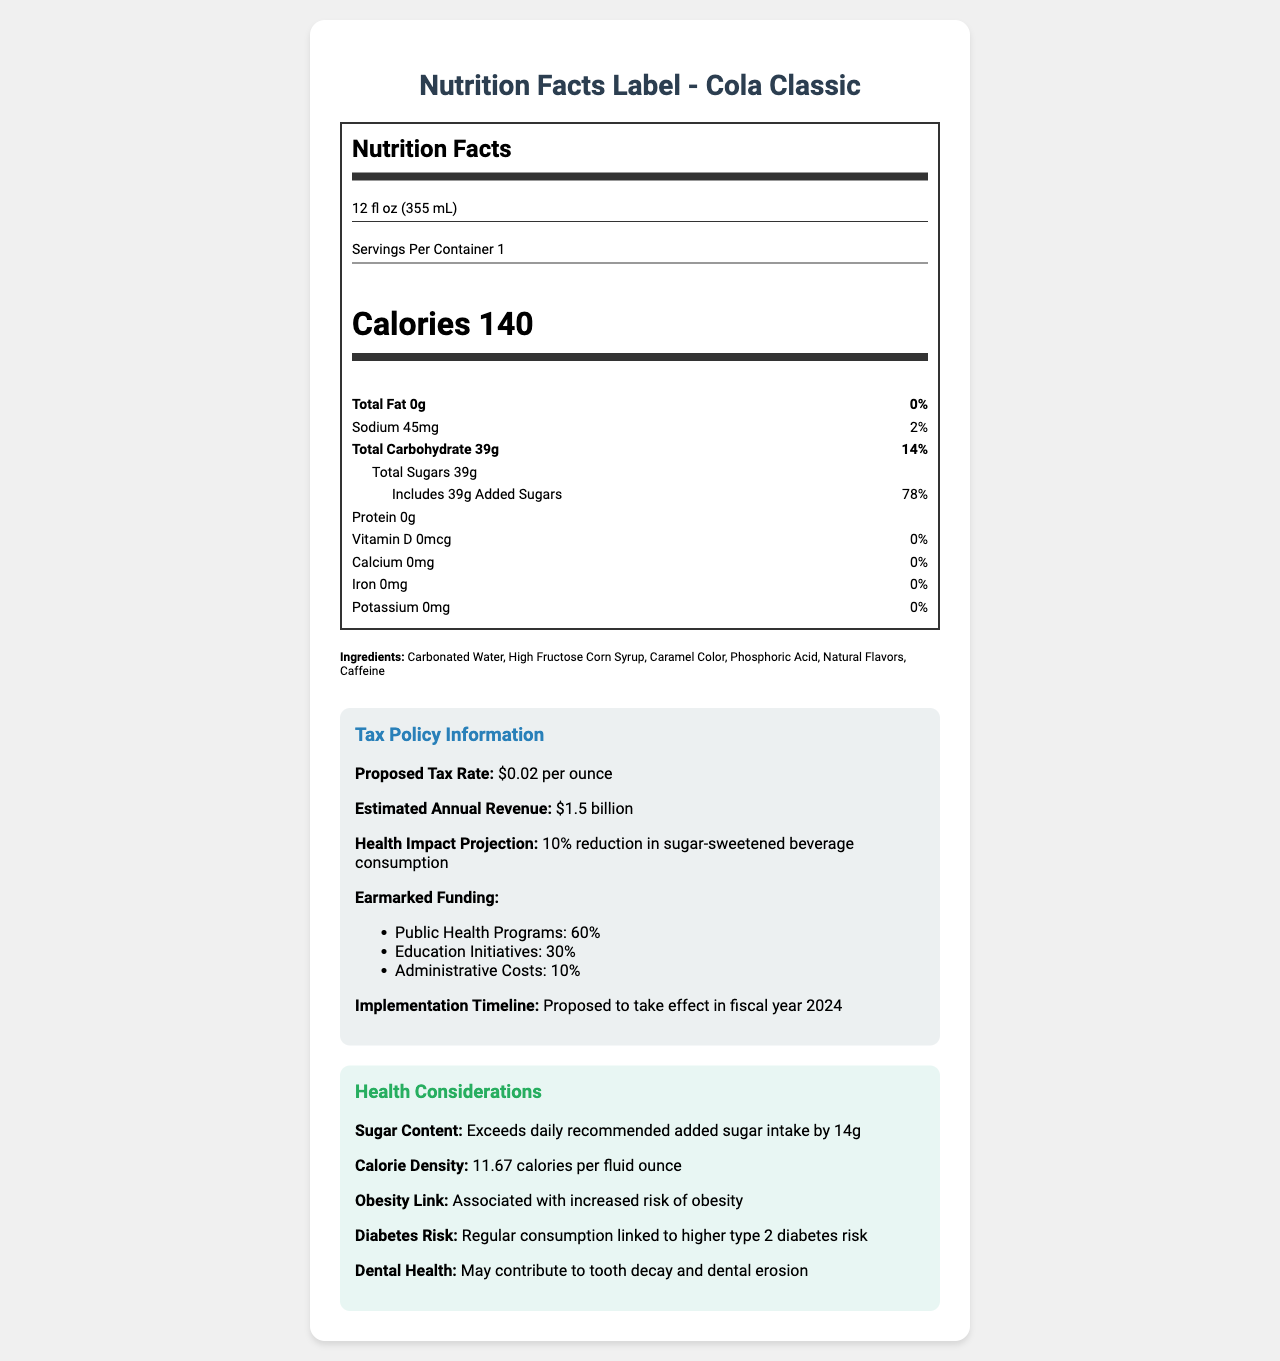what is the serving size of Cola Classic? The serving size is explicitly mentioned at the top of the Nutrition Facts section as "12 fl oz (355 mL)."
Answer: 12 fl oz (355 mL) How many calories are in one serving? The number of calories per serving is highlighted in bold and large font in the Nutrition Facts section as "Calories 140."
Answer: 140 calories What is the total carbohydrate content per serving? Under "Total Carbohydrate," the amount is listed as 39g.
Answer: 39g How much of the total carbohydrate content is sugar? The document specifies "Total Sugars" as 39g, which is the same as the total carbohydrate content, implying all the carbs come from sugar.
Answer: 39g Which ingredient is listed first in the ingredients list? The ingredients are listed in descending order of predominance by weight, and the first ingredient listed is "Carbonated Water."
Answer: Carbonated Water What is the proposed tax rate for sugar-sweetened beverages? This information is found in the Tax Policy Information section under "Proposed Tax Rate."
Answer: $0.02 per ounce How much revenue is the proposed tax expected to generate annually? The estimated annual revenue is mentioned as "$1.5 billion."
Answer: $1.5 billion How much of the proposed tax revenue is earmarked for public health programs? A. 10% B. 30% C. 60% D. 90% The Earmarked Funding section states that 60% of the revenue will go to Public Health Programs.
Answer: C What is the daily value percentage for added sugars in one serving? A. 14% B. 32% C. 78% D. 100% The Added Sugars section states the daily value percentage as "78%."
Answer: C Is calcium present in the Cola Classic beverage? The amount of calcium is listed as 0mg, with 0% daily value.
Answer: No Summarize the overall nutritional and health considerations of Cola Classic and the proposed tax policy. The document provides detailed nutritional information for a 12 fl oz serving of Cola Classic, emphasizing its high sugar content. It also outlines a new tax policy designed to curb sugar-sweetened beverage consumption, highlighting projected revenue and health benefits.
Answer: Cola Classic has 140 calories per serving, all from carbohydrates and sugar (39g total). It contains no fat, protein, or significant vitamins and minerals. The proposed sugar-sweetened beverage tax rate is $0.02 per ounce, expected to generate $1.5 billion annually, with significant portions allocated to public health and education. Potential health impacts include reductions in obesity and diabetes risk due to decreased consumption. Does Cola Classic contain vitamin D? The Vitamin D content is listed as 0mcg with a 0% daily value.
Answer: No How does the sugar content in Cola Classic compare to the daily recommended added sugar intake? The comparison to dietary guidelines states that the sugar content exceeds the daily recommended added sugar intake by 14g.
Answer: Exceeds by 14g What is the implementation timeline for the proposed sugar-sweetened beverage tax? The implementation timeline is specified as the fiscal year 2024 in the tax policy notes.
Answer: Proposed to take effect in fiscal year 2024 What are the primary health risks associated with the regular consumption of sugar-sweetened beverages like Cola Classic mentioned in the document? A. Increased risk of obesity B. Higher type 2 diabetes risk C. Tooth decay and dental erosion D. All of the above The health considerations section mentions all these risks, including obesity, diabetes, and dental health issues, indicating "All of the above" is correct.
Answer: D What percentage of the proposed tax revenue is earmarked for administrative costs? The earmarked funding details state that 10% of the revenue will cover administrative costs.
Answer: 10% What is the calorie density of Cola Classic? The comparison to dietary guidelines section specifies the calorie density as "11.67 calories per fluid ounce."
Answer: 11.67 calories per fluid ounce What is the relationship between Cola Classic and iron content? The iron amount is listed as 0mg, with a 0% daily value, indicating the beverage has no iron content.
Answer: No iron content Are any natural flavors listed in the ingredients? "Natural Flavors" are explicitly listed among the ingredients.
Answer: Yes What is the difference in sugar content between Cola Classic and a diet soda variant of similar quantity? The document does not provide any details about a diet soda variant for comparison.
Answer: Not enough information 